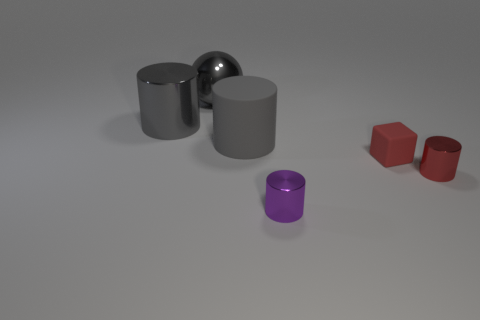What is the size of the gray object that is in front of the gray shiny cylinder?
Keep it short and to the point. Large. What is the material of the small red object left of the cylinder that is right of the purple metal thing?
Your answer should be very brief. Rubber. There is a metallic object that is in front of the small red thing that is to the right of the small red rubber thing; how many large metal balls are in front of it?
Keep it short and to the point. 0. Is the tiny object that is right of the red matte cube made of the same material as the gray thing that is to the right of the big gray shiny ball?
Offer a very short reply. No. There is a sphere that is the same color as the large rubber cylinder; what is it made of?
Make the answer very short. Metal. How many red objects have the same shape as the gray matte object?
Ensure brevity in your answer.  1. Is the number of small red metal objects that are in front of the small red cylinder greater than the number of shiny spheres?
Keep it short and to the point. No. The metal object that is in front of the tiny thing on the right side of the matte thing that is to the right of the gray rubber object is what shape?
Provide a succinct answer. Cylinder. There is a metallic thing that is on the right side of the tiny purple cylinder; is its shape the same as the small object left of the cube?
Your answer should be compact. Yes. Is there any other thing that has the same size as the gray rubber cylinder?
Provide a succinct answer. Yes. 